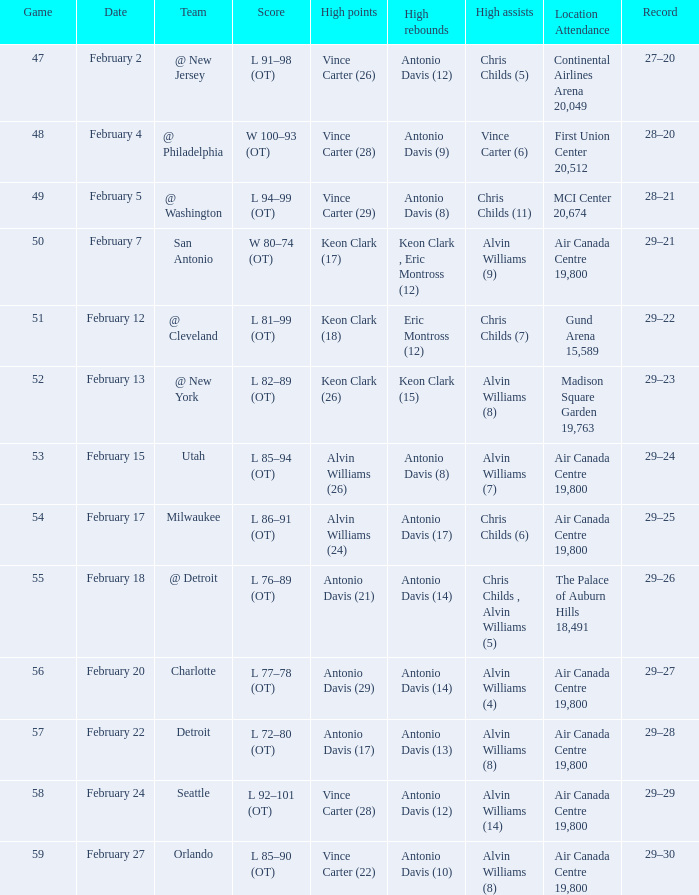What is the record for the most rebounds by antonio davis (9)? 28–20. 